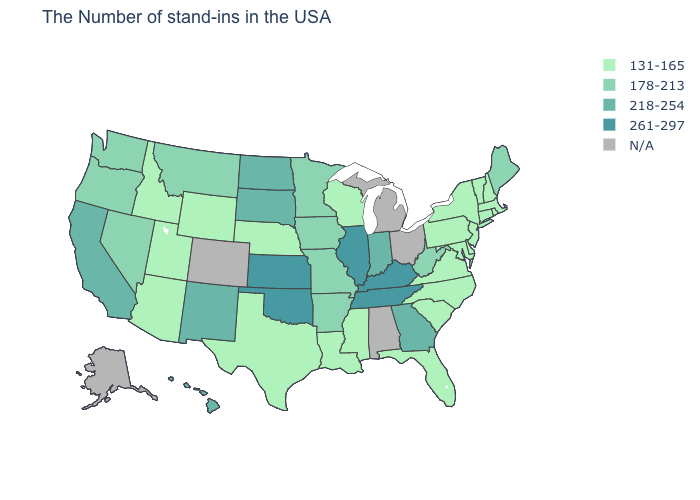How many symbols are there in the legend?
Quick response, please. 5. What is the value of Massachusetts?
Give a very brief answer. 131-165. Name the states that have a value in the range 131-165?
Write a very short answer. Massachusetts, Rhode Island, New Hampshire, Vermont, Connecticut, New York, New Jersey, Delaware, Maryland, Pennsylvania, Virginia, North Carolina, South Carolina, Florida, Wisconsin, Mississippi, Louisiana, Nebraska, Texas, Wyoming, Utah, Arizona, Idaho. What is the value of Connecticut?
Give a very brief answer. 131-165. Among the states that border Tennessee , does Kentucky have the highest value?
Quick response, please. Yes. What is the lowest value in the USA?
Write a very short answer. 131-165. Does North Dakota have the highest value in the MidWest?
Short answer required. No. What is the value of Hawaii?
Answer briefly. 218-254. Does Vermont have the lowest value in the USA?
Concise answer only. Yes. Name the states that have a value in the range 218-254?
Give a very brief answer. Georgia, Indiana, South Dakota, North Dakota, New Mexico, California, Hawaii. How many symbols are there in the legend?
Quick response, please. 5. 